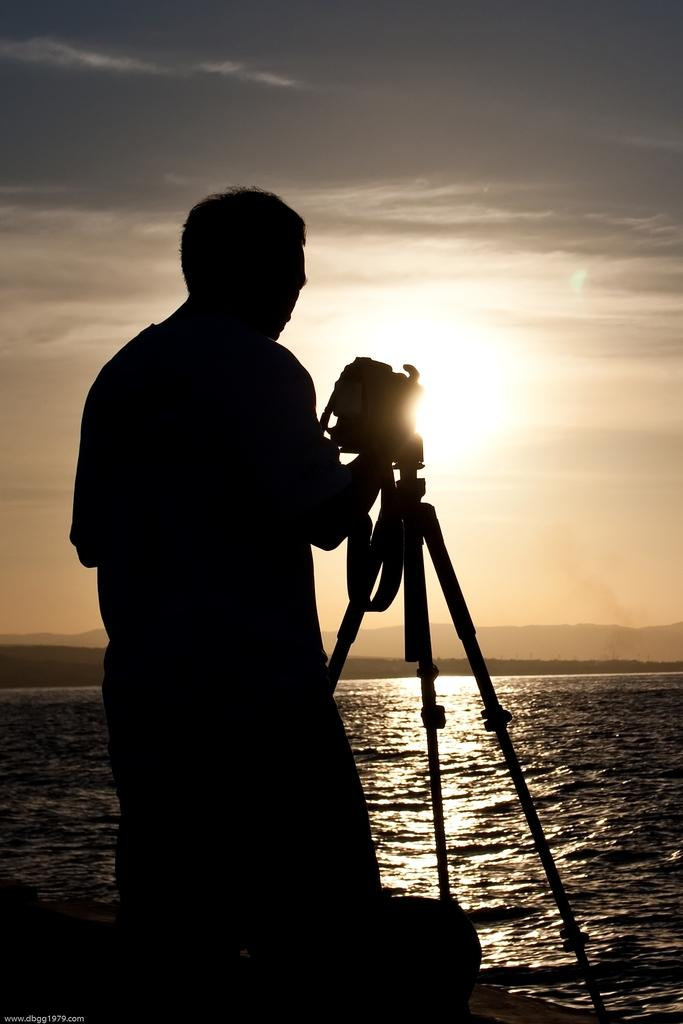What can be seen in the image that suggests someone is taking a photo? There is a shadow of a person holding a camera in the image. What equipment is visible in the image that might be used for photography? There is a camera stand in the image. What natural features can be seen in the background of the image? There is water, mountains, and the sky visible in the background of the image. Can the sun be seen in the image? Yes, the sun is observable in the sky. What type of account is being managed by the person holding the scissors in the image? There are no scissors or accounts present in the image. How does the person's sense of balance affect their ability to take a photo in the image? There is no indication of the person's sense of balance or any potential impact on their ability to take a photo in the image. 